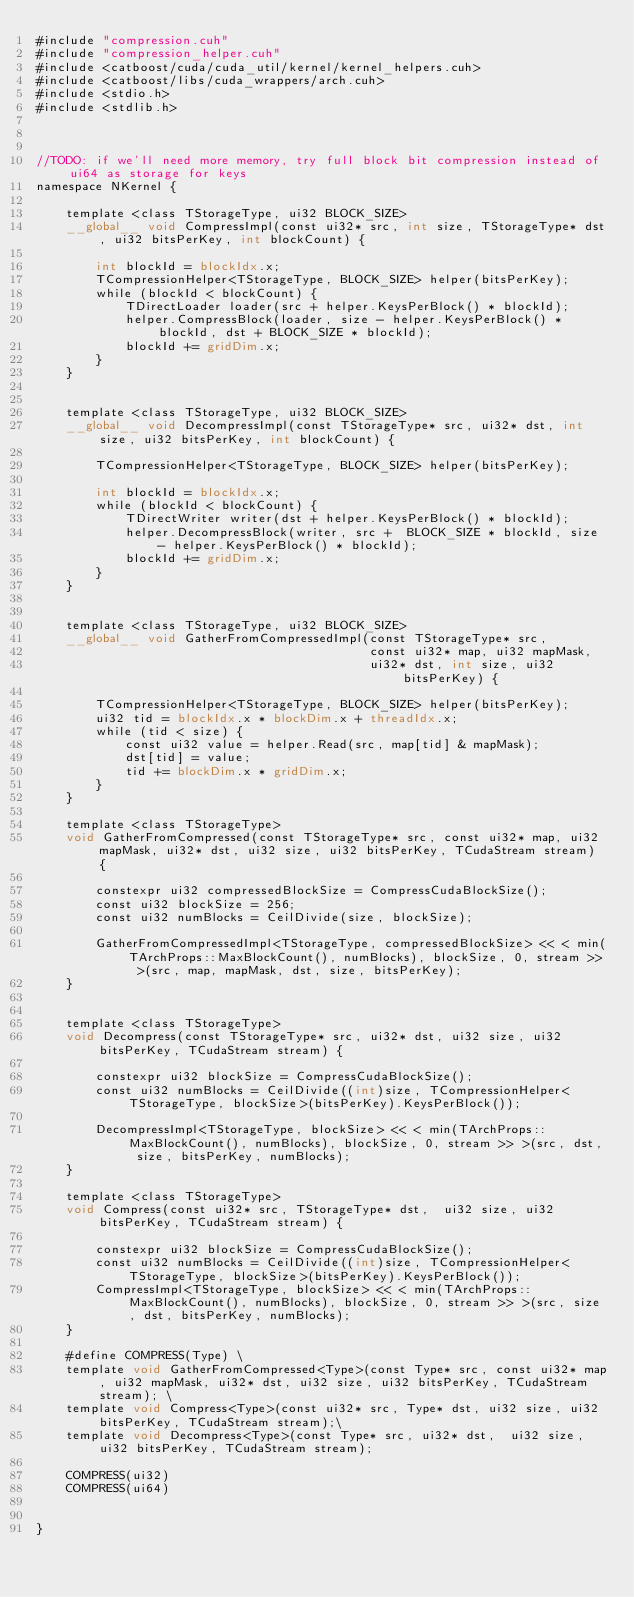<code> <loc_0><loc_0><loc_500><loc_500><_Cuda_>#include "compression.cuh"
#include "compression_helper.cuh"
#include <catboost/cuda/cuda_util/kernel/kernel_helpers.cuh>
#include <catboost/libs/cuda_wrappers/arch.cuh>
#include <stdio.h>
#include <stdlib.h>



//TODO: if we'll need more memory, try full block bit compression instead of ui64 as storage for keys
namespace NKernel {

    template <class TStorageType, ui32 BLOCK_SIZE>
    __global__ void CompressImpl(const ui32* src, int size, TStorageType* dst, ui32 bitsPerKey, int blockCount) {

        int blockId = blockIdx.x;
        TCompressionHelper<TStorageType, BLOCK_SIZE> helper(bitsPerKey);
        while (blockId < blockCount) {
            TDirectLoader loader(src + helper.KeysPerBlock() * blockId);
            helper.CompressBlock(loader, size - helper.KeysPerBlock() * blockId, dst + BLOCK_SIZE * blockId);
            blockId += gridDim.x;
        }
    }


    template <class TStorageType, ui32 BLOCK_SIZE>
    __global__ void DecompressImpl(const TStorageType* src, ui32* dst, int size, ui32 bitsPerKey, int blockCount) {

        TCompressionHelper<TStorageType, BLOCK_SIZE> helper(bitsPerKey);

        int blockId = blockIdx.x;
        while (blockId < blockCount) {
            TDirectWriter writer(dst + helper.KeysPerBlock() * blockId);
            helper.DecompressBlock(writer, src +  BLOCK_SIZE * blockId, size - helper.KeysPerBlock() * blockId);
            blockId += gridDim.x;
        }
    }


    template <class TStorageType, ui32 BLOCK_SIZE>
    __global__ void GatherFromCompressedImpl(const TStorageType* src,
                                             const ui32* map, ui32 mapMask,
                                             ui32* dst, int size, ui32 bitsPerKey) {

        TCompressionHelper<TStorageType, BLOCK_SIZE> helper(bitsPerKey);
        ui32 tid = blockIdx.x * blockDim.x + threadIdx.x;
        while (tid < size) {
            const ui32 value = helper.Read(src, map[tid] & mapMask);
            dst[tid] = value;
            tid += blockDim.x * gridDim.x;
        }
    }

    template <class TStorageType>
    void GatherFromCompressed(const TStorageType* src, const ui32* map, ui32 mapMask, ui32* dst, ui32 size, ui32 bitsPerKey, TCudaStream stream) {

        constexpr ui32 compressedBlockSize = CompressCudaBlockSize();
        const ui32 blockSize = 256;
        const ui32 numBlocks = CeilDivide(size, blockSize);

        GatherFromCompressedImpl<TStorageType, compressedBlockSize> << < min(TArchProps::MaxBlockCount(), numBlocks), blockSize, 0, stream >> >(src, map, mapMask, dst, size, bitsPerKey);
    }


    template <class TStorageType>
    void Decompress(const TStorageType* src, ui32* dst, ui32 size, ui32 bitsPerKey, TCudaStream stream) {

        constexpr ui32 blockSize = CompressCudaBlockSize();
        const ui32 numBlocks = CeilDivide((int)size, TCompressionHelper<TStorageType, blockSize>(bitsPerKey).KeysPerBlock());

        DecompressImpl<TStorageType, blockSize> << < min(TArchProps::MaxBlockCount(), numBlocks), blockSize, 0, stream >> >(src, dst, size, bitsPerKey, numBlocks);
    }

    template <class TStorageType>
    void Compress(const ui32* src, TStorageType* dst,  ui32 size, ui32 bitsPerKey, TCudaStream stream) {

        constexpr ui32 blockSize = CompressCudaBlockSize();
        const ui32 numBlocks = CeilDivide((int)size, TCompressionHelper<TStorageType, blockSize>(bitsPerKey).KeysPerBlock());
        CompressImpl<TStorageType, blockSize> << < min(TArchProps::MaxBlockCount(), numBlocks), blockSize, 0, stream >> >(src, size, dst, bitsPerKey, numBlocks);
    }

    #define COMPRESS(Type) \
    template void GatherFromCompressed<Type>(const Type* src, const ui32* map, ui32 mapMask, ui32* dst, ui32 size, ui32 bitsPerKey, TCudaStream stream); \
    template void Compress<Type>(const ui32* src, Type* dst, ui32 size, ui32 bitsPerKey, TCudaStream stream);\
    template void Decompress<Type>(const Type* src, ui32* dst,  ui32 size, ui32 bitsPerKey, TCudaStream stream);

    COMPRESS(ui32)
    COMPRESS(ui64)


}




</code> 